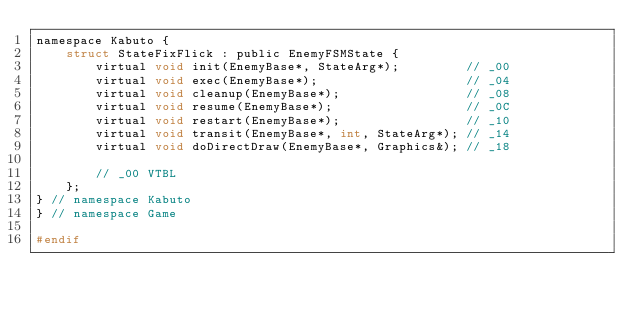Convert code to text. <code><loc_0><loc_0><loc_500><loc_500><_C_>namespace Kabuto {
	struct StateFixFlick : public EnemyFSMState {
		virtual void init(EnemyBase*, StateArg*);         // _00
		virtual void exec(EnemyBase*);                    // _04
		virtual void cleanup(EnemyBase*);                 // _08
		virtual void resume(EnemyBase*);                  // _0C
		virtual void restart(EnemyBase*);                 // _10
		virtual void transit(EnemyBase*, int, StateArg*); // _14
		virtual void doDirectDraw(EnemyBase*, Graphics&); // _18

		// _00 VTBL
	};
} // namespace Kabuto
} // namespace Game

#endif
</code> 